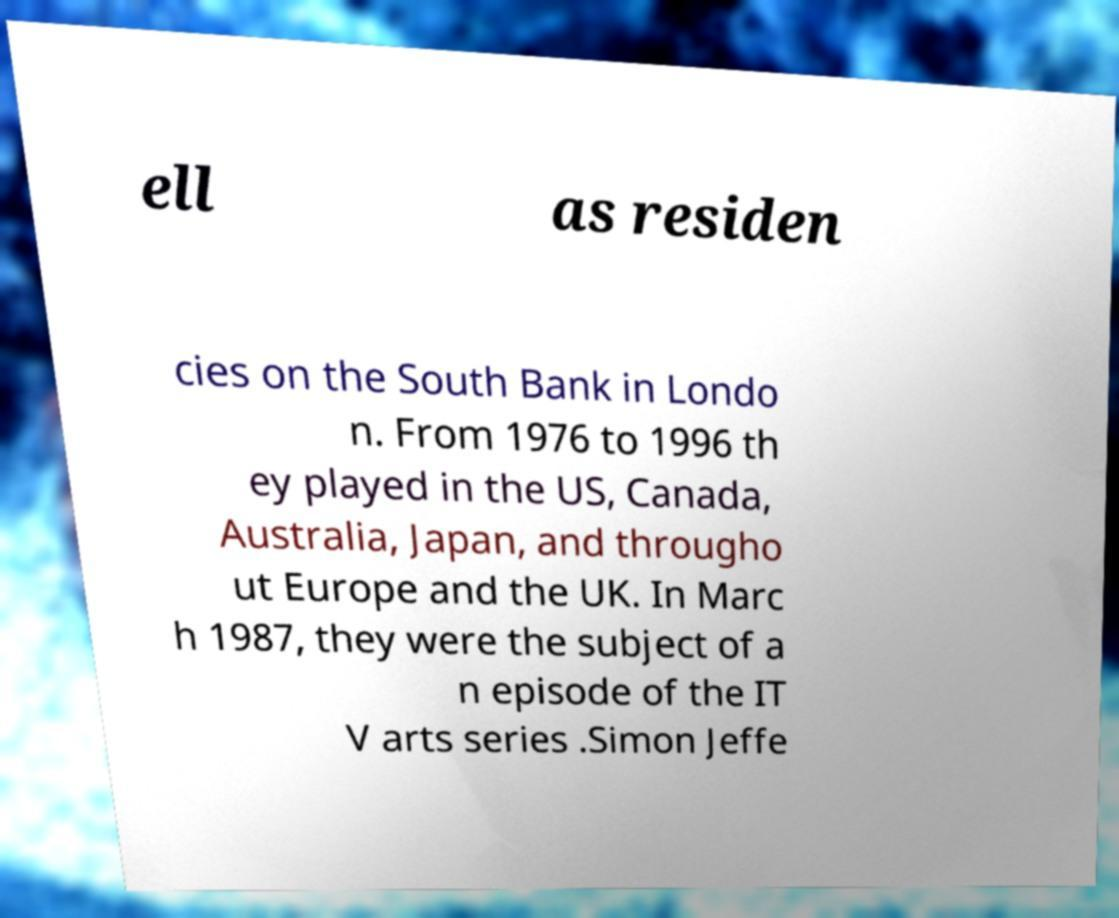Please identify and transcribe the text found in this image. ell as residen cies on the South Bank in Londo n. From 1976 to 1996 th ey played in the US, Canada, Australia, Japan, and througho ut Europe and the UK. In Marc h 1987, they were the subject of a n episode of the IT V arts series .Simon Jeffe 